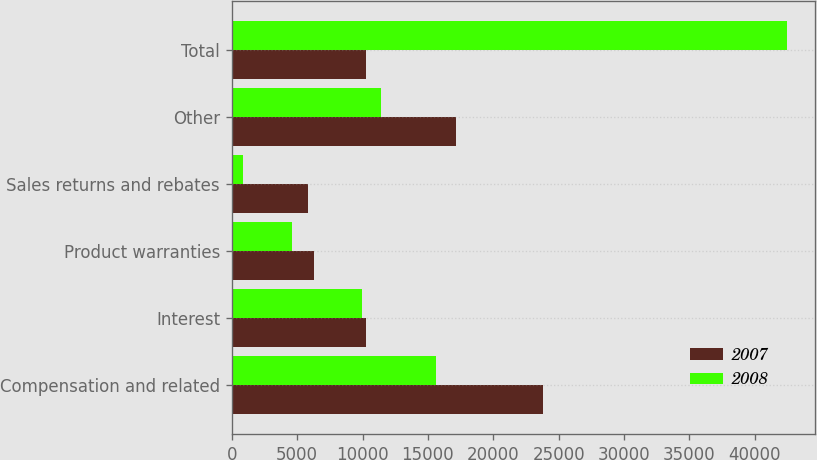<chart> <loc_0><loc_0><loc_500><loc_500><stacked_bar_chart><ecel><fcel>Compensation and related<fcel>Interest<fcel>Product warranties<fcel>Sales returns and rebates<fcel>Other<fcel>Total<nl><fcel>2007<fcel>23826<fcel>10266<fcel>6255<fcel>5858<fcel>17157<fcel>10266<nl><fcel>2008<fcel>15651<fcel>9930<fcel>4624<fcel>829<fcel>11432<fcel>42466<nl></chart> 